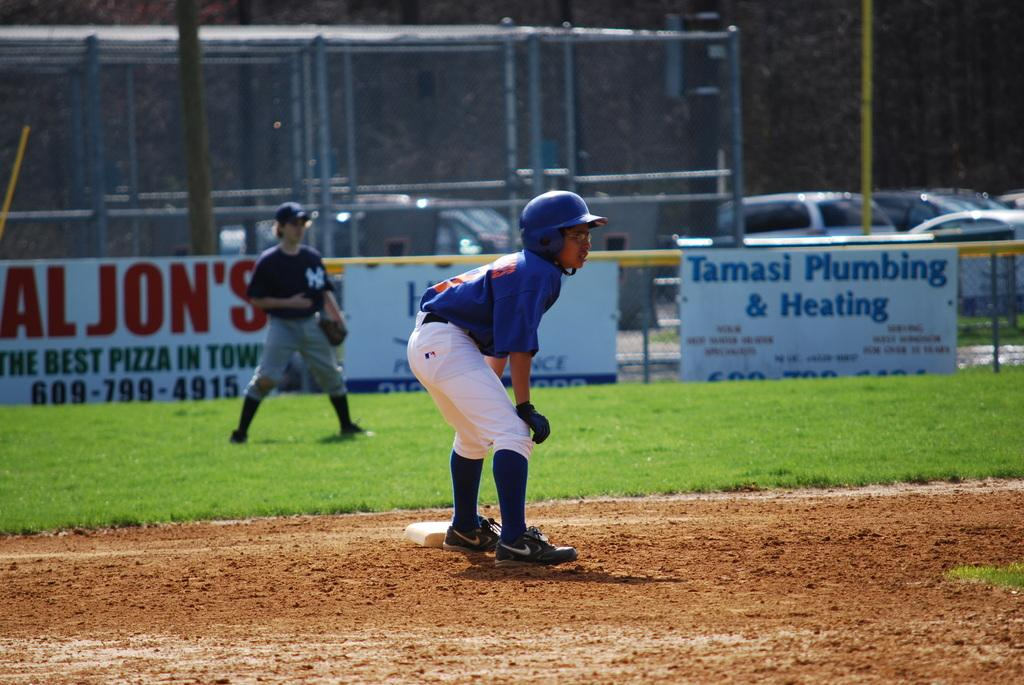How many kids are in the image? There are two kids standing in the image. What can be seen in the background of the image? Boards, vehicles, objects resembling trees, and a fence are visible in the background. What type of key is being used to unlock the mine in the image? There is no mine or key present in the image. Is there a basketball game happening in the background of the image? There is no basketball game or any reference to a basketball in the image. 